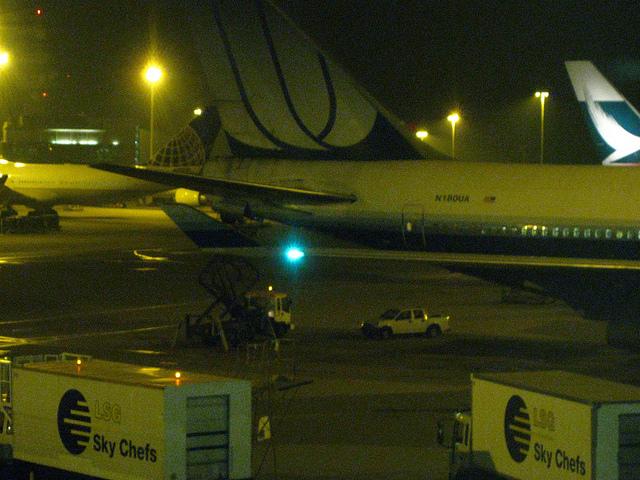Is the plane ready for takeoff?
Concise answer only. Yes. What are the letters on the trucks?
Concise answer only. Sky chefs. What airline is this?
Give a very brief answer. Sky chefs. Is the sun out?
Answer briefly. No. 